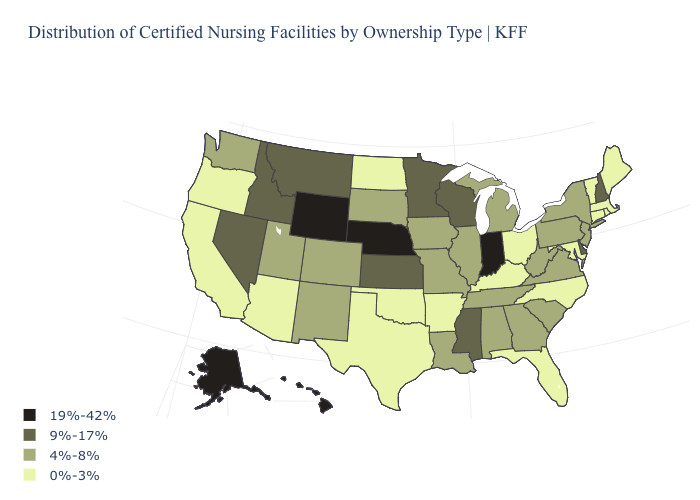Which states hav the highest value in the West?
Concise answer only. Alaska, Hawaii, Wyoming. What is the value of Ohio?
Give a very brief answer. 0%-3%. Name the states that have a value in the range 9%-17%?
Give a very brief answer. Delaware, Idaho, Kansas, Minnesota, Mississippi, Montana, Nevada, New Hampshire, Wisconsin. What is the value of South Carolina?
Be succinct. 4%-8%. Does the map have missing data?
Short answer required. No. Which states have the lowest value in the South?
Quick response, please. Arkansas, Florida, Kentucky, Maryland, North Carolina, Oklahoma, Texas. Which states hav the highest value in the West?
Give a very brief answer. Alaska, Hawaii, Wyoming. How many symbols are there in the legend?
Answer briefly. 4. Does Georgia have the lowest value in the USA?
Keep it brief. No. What is the value of Illinois?
Keep it brief. 4%-8%. Does New Mexico have the same value as Virginia?
Quick response, please. Yes. Does the map have missing data?
Short answer required. No. Does New Jersey have the lowest value in the Northeast?
Give a very brief answer. No. Does the map have missing data?
Answer briefly. No. Is the legend a continuous bar?
Write a very short answer. No. 